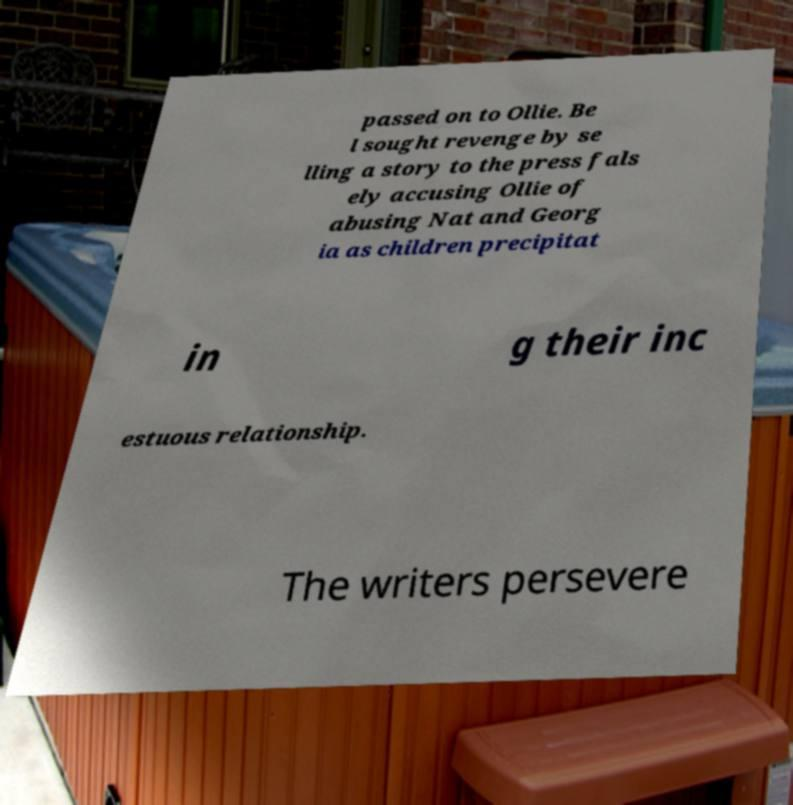For documentation purposes, I need the text within this image transcribed. Could you provide that? passed on to Ollie. Be l sought revenge by se lling a story to the press fals ely accusing Ollie of abusing Nat and Georg ia as children precipitat in g their inc estuous relationship. The writers persevere 